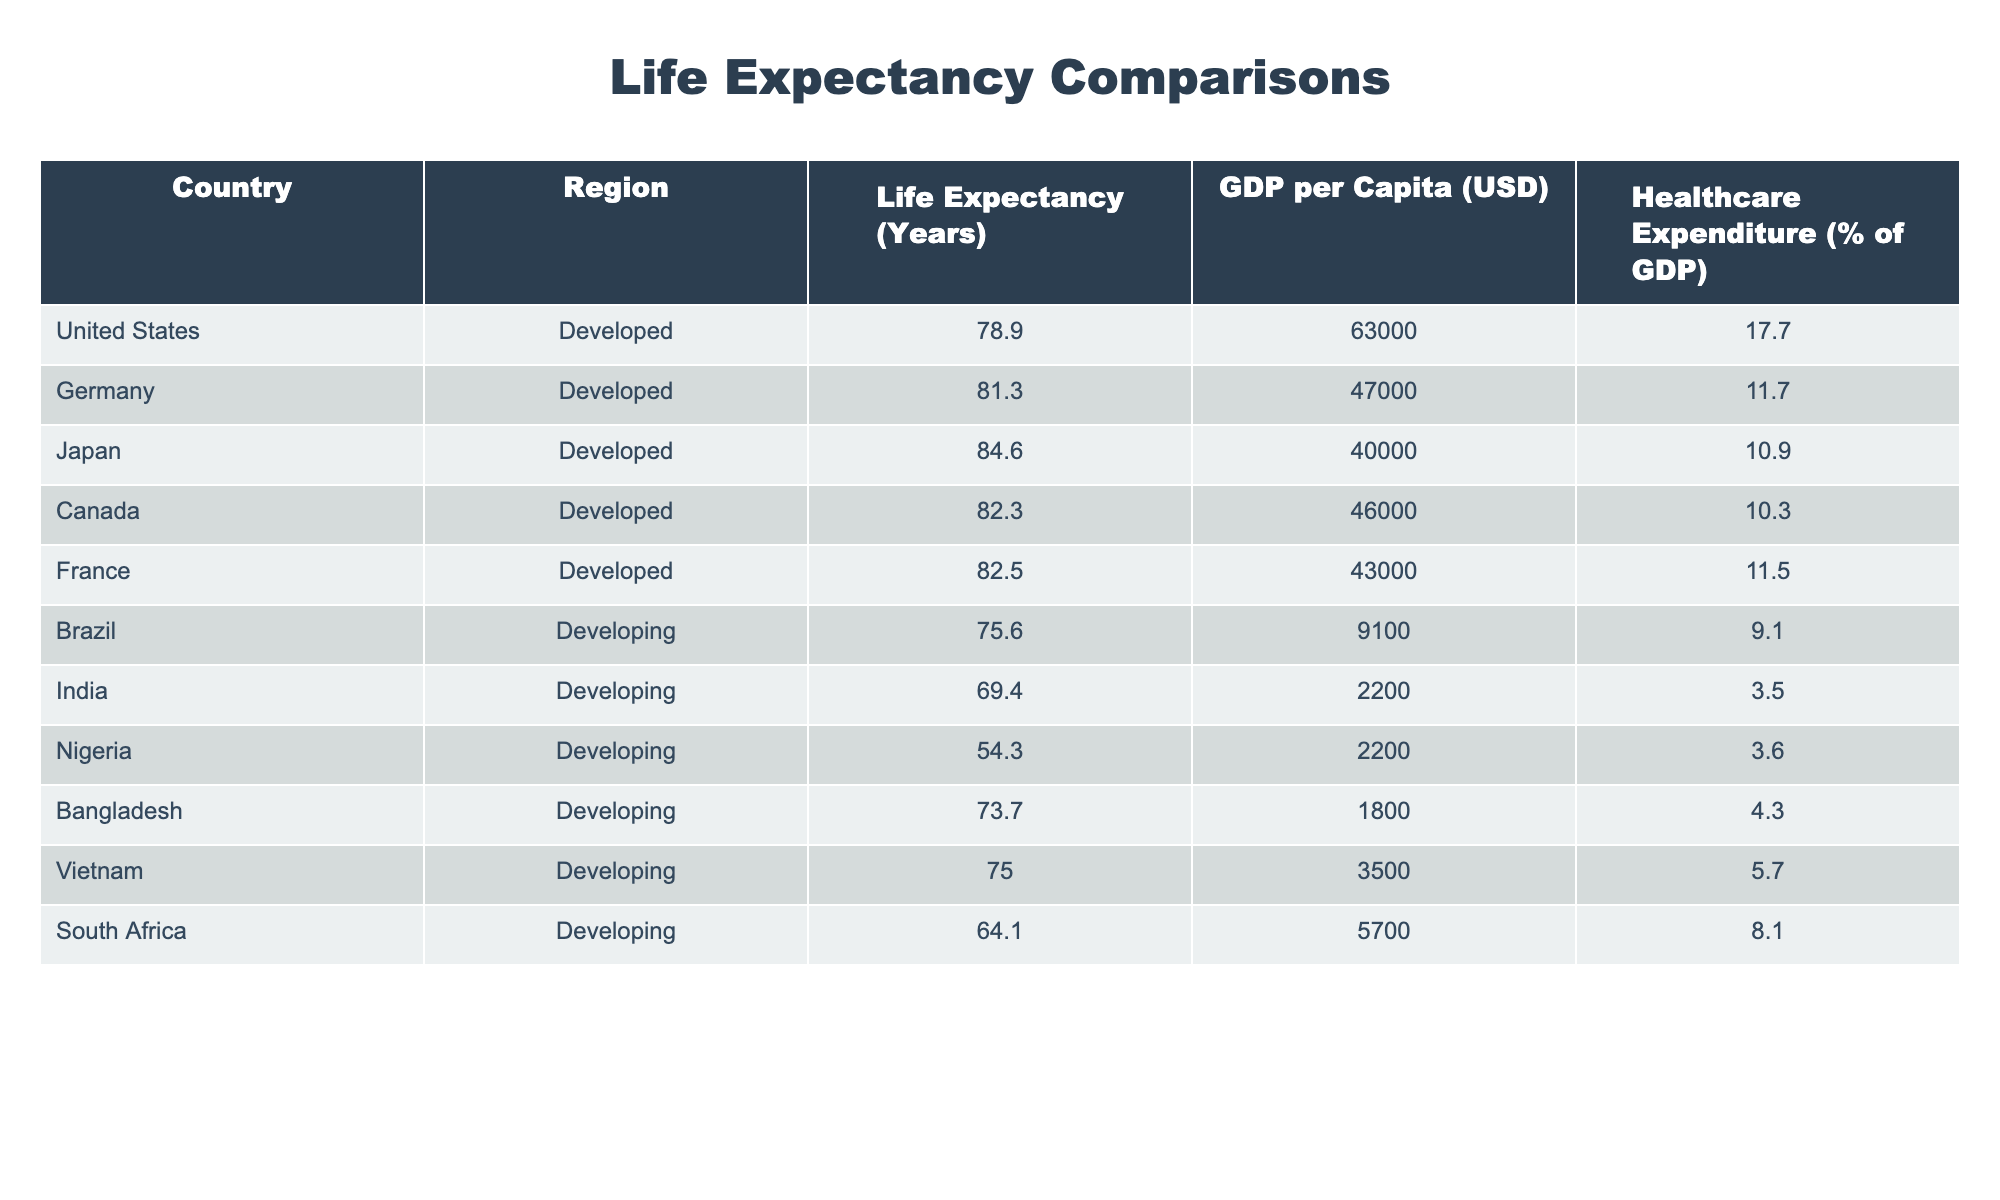What is the life expectancy of the United States? The table lists the life expectancy for each country, and for the United States, it is explicitly stated as 78.9 years.
Answer: 78.9 years Which country has the highest life expectancy? By comparing the life expectancies of all the countries listed in the table, Japan has the highest life expectancy at 84.6 years.
Answer: Japan What is the average life expectancy of developed countries listed in the table? The life expectancies for developed countries are: 78.9 (USA), 81.3 (Germany), 84.6 (Japan), 82.3 (Canada), and 82.5 (France). Adding these yields 409.6. There are 5 countries, so the average is 409.6 / 5 = 81.92 years.
Answer: 81.92 years Is the life expectancy in India greater than 70 years? The table specifies India's life expectancy as 69.4 years, which is less than 70 years, making the statement false.
Answer: No What is the difference in life expectancy between Germany and Nigeria? Germany's life expectancy is 81.3 years, while Nigeria's is 54.3 years. The difference is calculated as 81.3 - 54.3 = 27 years.
Answer: 27 years Are all developing countries in the table below an average life expectancy of 70 years? The life expectancies of developing countries listed are: 75.6 (Brazil), 69.4 (India), 54.3 (Nigeria), 73.7 (Bangladesh), 75.0 (Vietnam), and 64.1 (South Africa). The average is (75.6 + 69.4 + 54.3 + 73.7 + 75.0 + 64.1) / 6 = 68.85 years, which is below 70 years, so the answer is yes.
Answer: Yes What is the median life expectancy among the developing countries? The life expectancies of developing countries in ascending order are: 54.3 (Nigeria), 64.1 (South Africa), 69.4 (India), 73.7 (Bangladesh), 75.0 (Vietnam), and 75.6 (Brazil). The median is the average of 69.4 and 73.7, which equals (69.4 + 73.7) / 2 = 71.55 years.
Answer: 71.55 years Which region has a higher average healthcare expenditure as a percentage of GDP? The table shows developed countries have an average healthcare expenditure of (17.7 + 11.7 + 10.9 + 10.3 + 11.5) / 5 = 12.42%, while developing countries have (9.1 + 3.5 + 3.6 + 4.3 + 5.7 + 8.1) / 6 = 5.58%. Since 12.42% > 5.58%, developed countries have higher average healthcare expenditure.
Answer: Developed What is the GDP per capita of the country with the lowest life expectancy? Nigeria has the lowest life expectancy at 54.3 years, and its GDP per capita is listed as 2200 USD.
Answer: 2200 USD 